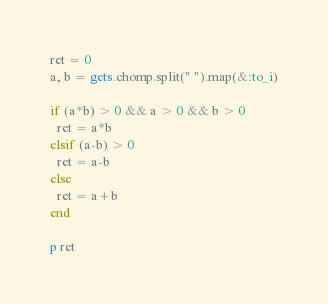Convert code to text. <code><loc_0><loc_0><loc_500><loc_500><_Ruby_>ret = 0
a, b = gets.chomp.split(" ").map(&:to_i)

if (a*b) > 0 && a > 0 && b > 0
  ret = a*b
elsif (a-b) > 0
  ret = a-b
else
  ret = a+b
end

p ret</code> 